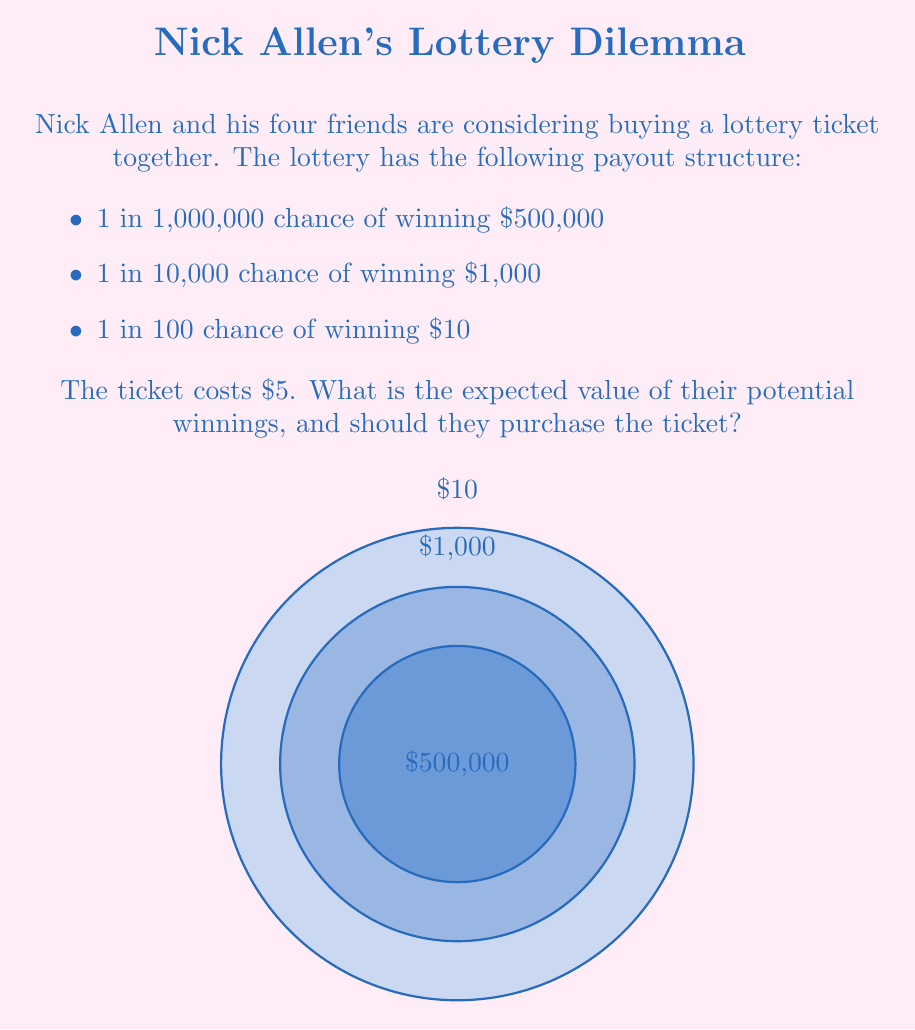What is the answer to this math problem? Let's calculate the expected value of the lottery ticket:

1) First, we need to calculate the probability and expected value for each outcome:

   a) $500,000 prize:
      P(winning) = 1/1,000,000
      Expected value = $500,000 * (1/1,000,000) = $0.50

   b) $1,000 prize:
      P(winning) = 1/10,000
      Expected value = $1,000 * (1/10,000) = $0.10

   c) $10 prize:
      P(winning) = 1/100
      Expected value = $10 * (1/100) = $0.10

2) The total expected value is the sum of these individual expected values:

   $$ E = 0.50 + 0.10 + 0.10 = $0.70 $$

3) However, we need to subtract the cost of the ticket:

   $$ \text{Net Expected Value} = $0.70 - $5.00 = -$4.30 $$

4) The negative expected value means that, on average, they would lose $4.30 for each ticket purchased.

Therefore, from a purely mathematical standpoint, Nick and his friends should not purchase the ticket as the expected value is negative.
Answer: $-$4.30; No 